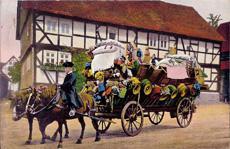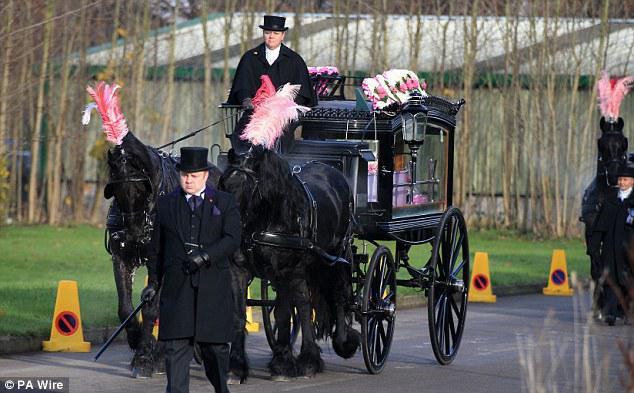The first image is the image on the left, the second image is the image on the right. Considering the images on both sides, is "All of the carts are being pulled by horses and none of the horses is being ridden by a person." valid? Answer yes or no. No. 